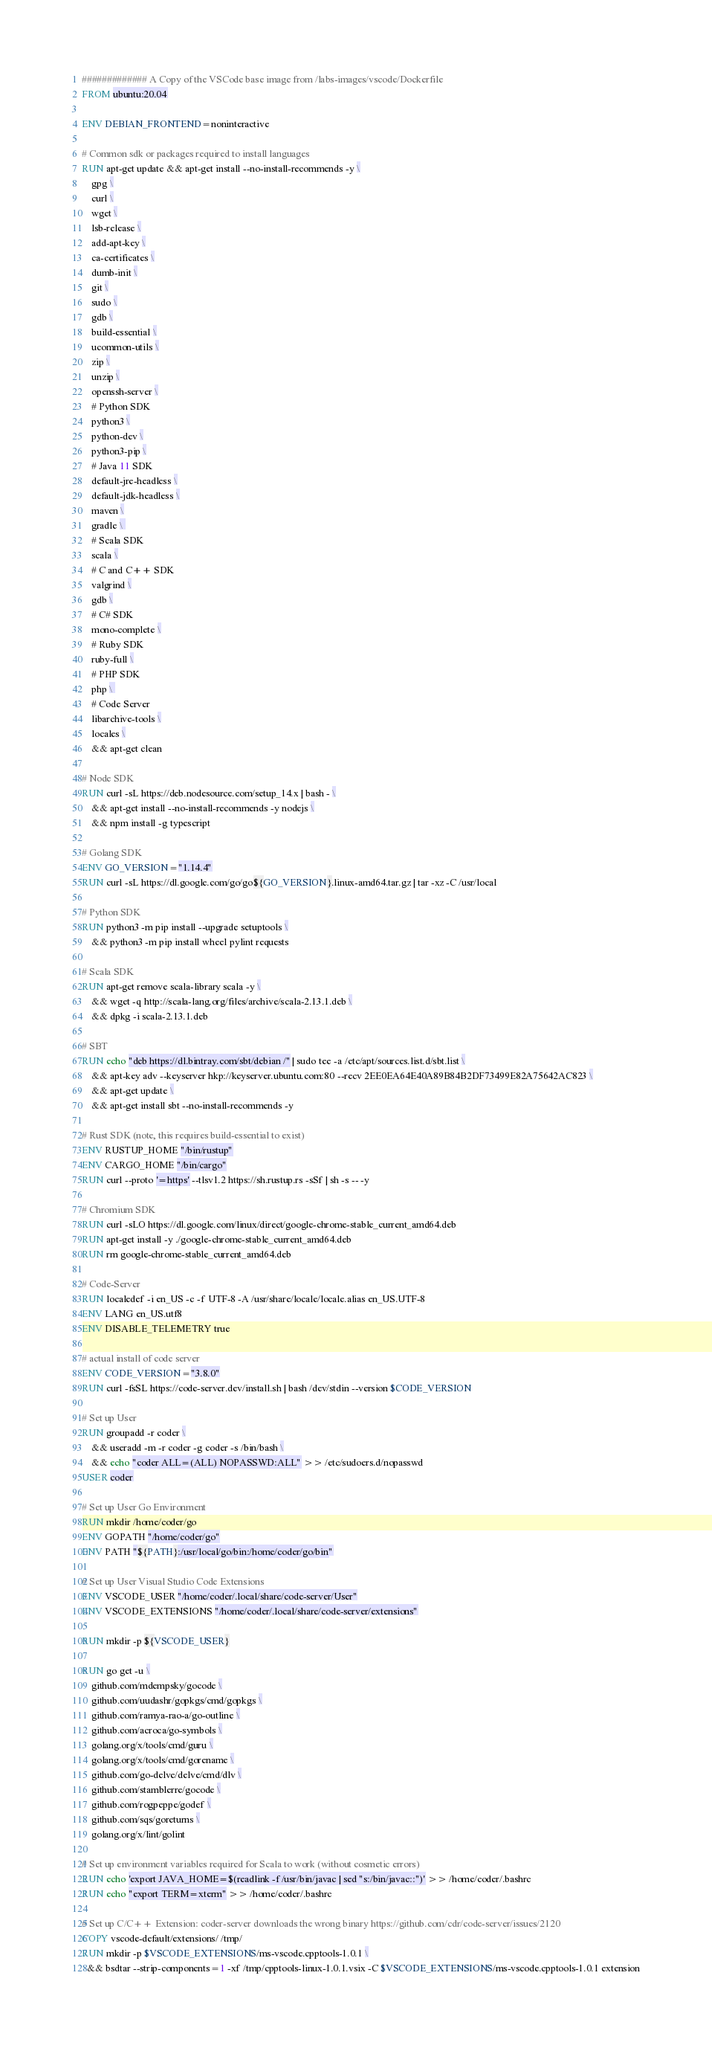<code> <loc_0><loc_0><loc_500><loc_500><_Dockerfile_>############# A Copy of the VSCode base image from /labs-images/vscode/Dockerfile
FROM ubuntu:20.04

ENV DEBIAN_FRONTEND=noninteractive

# Common sdk or packages required to install languages
RUN apt-get update && apt-get install --no-install-recommends -y \
    gpg \
    curl \
    wget \
    lsb-release \
    add-apt-key \
    ca-certificates \
    dumb-init \
    git \
    sudo \
    gdb \
    build-essential \
    ucommon-utils \
    zip \
    unzip \
    openssh-server \
    # Python SDK
    python3 \
    python-dev \
    python3-pip \
    # Java 11 SDK
    default-jre-headless \
    default-jdk-headless \
    maven \
    gradle \ 
    # Scala SDK
    scala \
    # C and C++ SDK
    valgrind \
    gdb \
    # C# SDK
    mono-complete \
    # Ruby SDK
    ruby-full \
    # PHP SDK
    php \ 
    # Code Server
    libarchive-tools \
    locales \
    && apt-get clean

# Node SDK
RUN curl -sL https://deb.nodesource.com/setup_14.x | bash - \
    && apt-get install --no-install-recommends -y nodejs \
    && npm install -g typescript

# Golang SDK
ENV GO_VERSION="1.14.4"
RUN curl -sL https://dl.google.com/go/go${GO_VERSION}.linux-amd64.tar.gz | tar -xz -C /usr/local

# Python SDK
RUN python3 -m pip install --upgrade setuptools \
    && python3 -m pip install wheel pylint requests

# Scala SDK
RUN apt-get remove scala-library scala -y \
    && wget -q http://scala-lang.org/files/archive/scala-2.13.1.deb \
    && dpkg -i scala-2.13.1.deb

# SBT
RUN echo "deb https://dl.bintray.com/sbt/debian /" | sudo tee -a /etc/apt/sources.list.d/sbt.list \
    && apt-key adv --keyserver hkp://keyserver.ubuntu.com:80 --recv 2EE0EA64E40A89B84B2DF73499E82A75642AC823 \
    && apt-get update \
    && apt-get install sbt --no-install-recommends -y

# Rust SDK (note, this requires build-essential to exist)
ENV RUSTUP_HOME "/bin/rustup"
ENV CARGO_HOME "/bin/cargo"
RUN curl --proto '=https' --tlsv1.2 https://sh.rustup.rs -sSf | sh -s -- -y

# Chromium SDK
RUN curl -sLO https://dl.google.com/linux/direct/google-chrome-stable_current_amd64.deb
RUN apt-get install -y ./google-chrome-stable_current_amd64.deb
RUN rm google-chrome-stable_current_amd64.deb

# Code-Server
RUN localedef -i en_US -c -f UTF-8 -A /usr/share/locale/locale.alias en_US.UTF-8
ENV LANG en_US.utf8
ENV DISABLE_TELEMETRY true

# actual install of code server
ENV CODE_VERSION="3.8.0"
RUN curl -fsSL https://code-server.dev/install.sh | bash /dev/stdin --version $CODE_VERSION

# Set up User
RUN groupadd -r coder \
    && useradd -m -r coder -g coder -s /bin/bash \
    && echo "coder ALL=(ALL) NOPASSWD:ALL" >> /etc/sudoers.d/nopasswd
USER coder

# Set up User Go Environment
RUN mkdir /home/coder/go
ENV GOPATH "/home/coder/go"
ENV PATH "${PATH}:/usr/local/go/bin:/home/coder/go/bin"

# Set up User Visual Studio Code Extensions
ENV VSCODE_USER "/home/coder/.local/share/code-server/User"
ENV VSCODE_EXTENSIONS "/home/coder/.local/share/code-server/extensions"

RUN mkdir -p ${VSCODE_USER}

RUN go get -u \
    github.com/mdempsky/gocode \
    github.com/uudashr/gopkgs/cmd/gopkgs \
    github.com/ramya-rao-a/go-outline \
    github.com/acroca/go-symbols \
    golang.org/x/tools/cmd/guru \
    golang.org/x/tools/cmd/gorename \
    github.com/go-delve/delve/cmd/dlv \
    github.com/stamblerre/gocode \
    github.com/rogpeppe/godef \
    github.com/sqs/goreturns \
    golang.org/x/lint/golint

# Set up environment variables required for Scala to work (without cosmetic errors)
RUN echo 'export JAVA_HOME=$(readlink -f /usr/bin/javac | sed "s:/bin/javac::")' >> /home/coder/.bashrc
RUN echo "export TERM=xterm" >> /home/coder/.bashrc

# Set up C/C++ Extension: coder-server downloads the wrong binary https://github.com/cdr/code-server/issues/2120
COPY vscode-default/extensions/ /tmp/
RUN mkdir -p $VSCODE_EXTENSIONS/ms-vscode.cpptools-1.0.1 \
  && bsdtar --strip-components=1 -xf /tmp/cpptools-linux-1.0.1.vsix -C $VSCODE_EXTENSIONS/ms-vscode.cpptools-1.0.1 extension</code> 